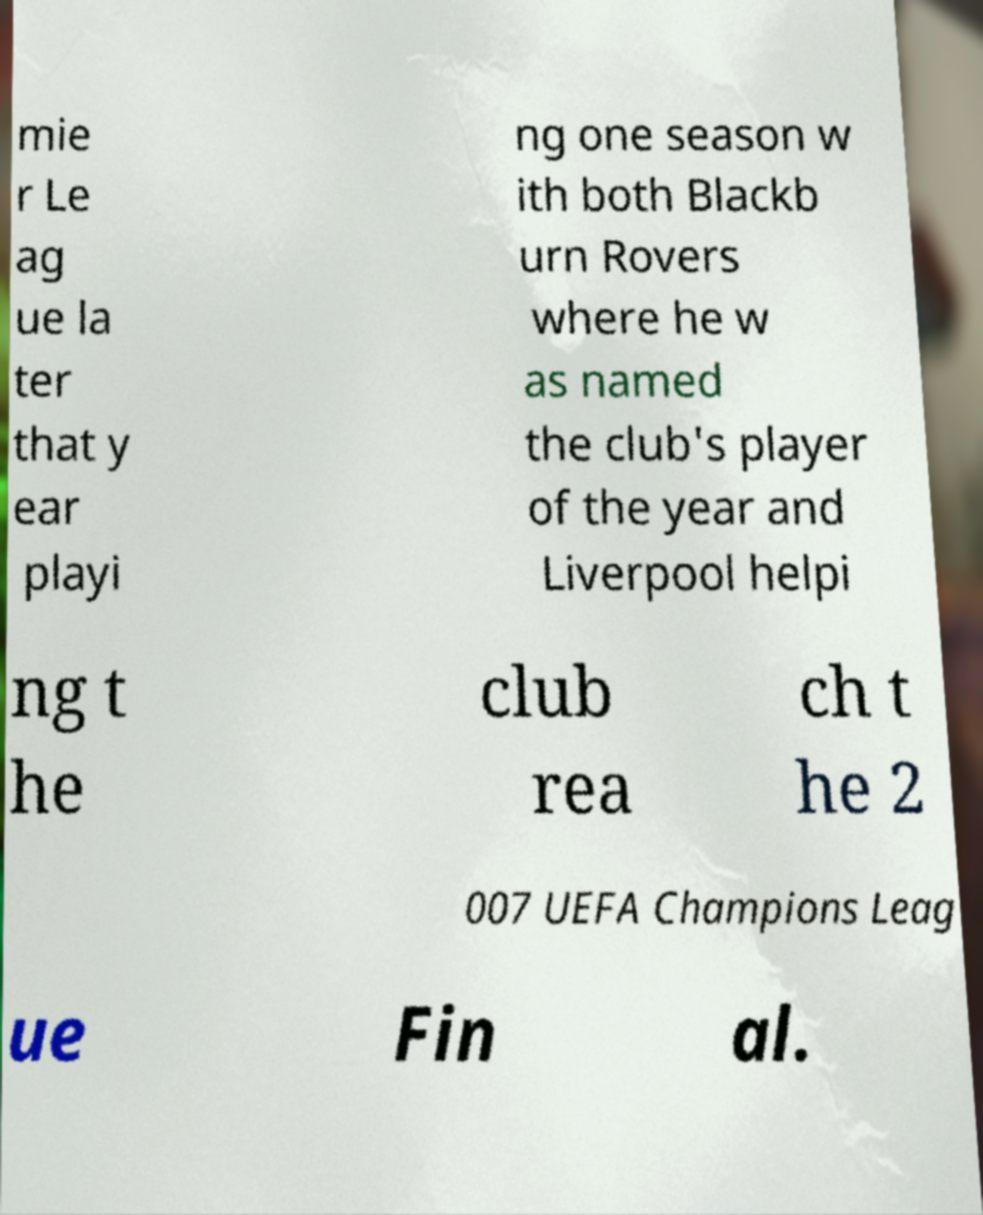Could you extract and type out the text from this image? mie r Le ag ue la ter that y ear playi ng one season w ith both Blackb urn Rovers where he w as named the club's player of the year and Liverpool helpi ng t he club rea ch t he 2 007 UEFA Champions Leag ue Fin al. 